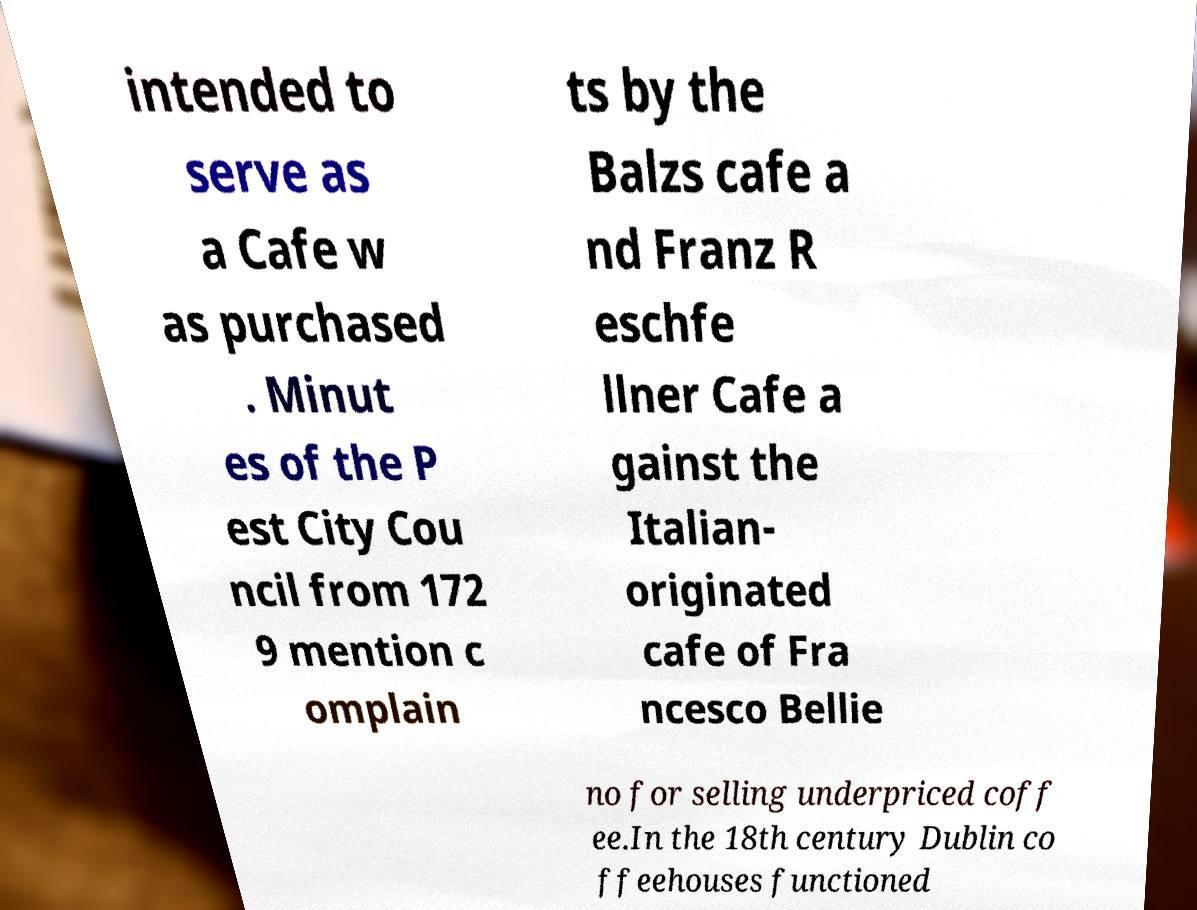There's text embedded in this image that I need extracted. Can you transcribe it verbatim? intended to serve as a Cafe w as purchased . Minut es of the P est City Cou ncil from 172 9 mention c omplain ts by the Balzs cafe a nd Franz R eschfe llner Cafe a gainst the Italian- originated cafe of Fra ncesco Bellie no for selling underpriced coff ee.In the 18th century Dublin co ffeehouses functioned 